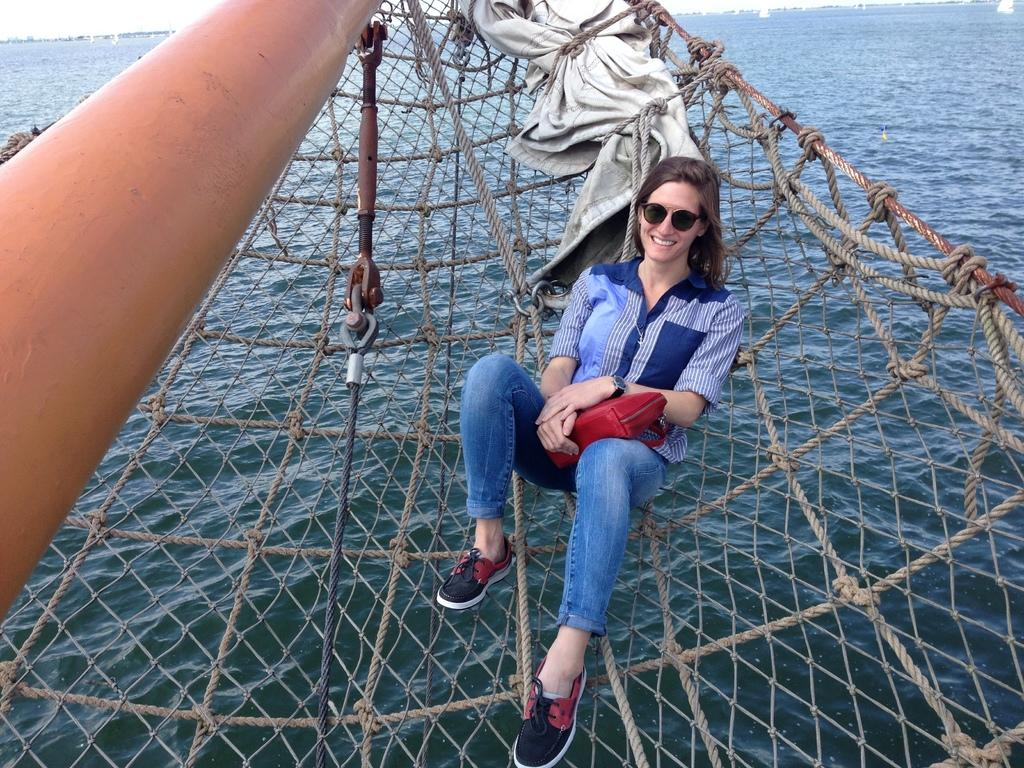Who is present in the image? There is a woman in the image. What is the woman wearing? The woman is wearing glasses. What is the woman sitting on? The woman is sitting on a net. What objects can be seen in the image besides the woman? There is a rod, cloth, and ropes in the image. What can be seen in the background of the image? There is water visible in the background of the image. What type of sidewalk can be seen in the image? There is no sidewalk present in the image. How many wings can be seen on the woman in the image? The woman in the image does not have any wings. 